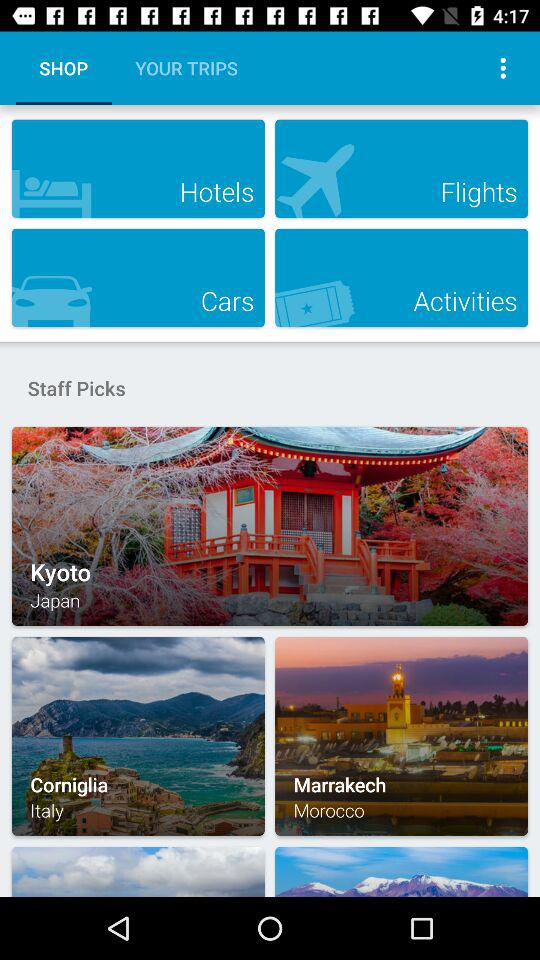Where is Kyoto situated? Kyoto is situated in Japan. 